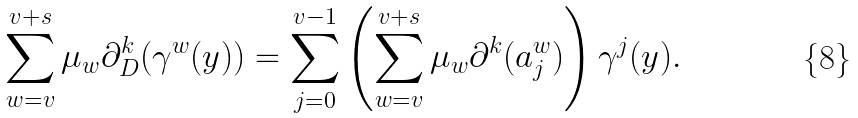Convert formula to latex. <formula><loc_0><loc_0><loc_500><loc_500>\sum _ { w = v } ^ { v + s } \mu _ { w } \partial _ { D } ^ { k } ( \gamma ^ { w } ( y ) ) = \sum _ { j = 0 } ^ { v - 1 } \left ( \sum _ { w = v } ^ { v + s } \mu _ { w } \partial ^ { k } ( a _ { j } ^ { w } ) \right ) \gamma ^ { j } ( y ) .</formula> 